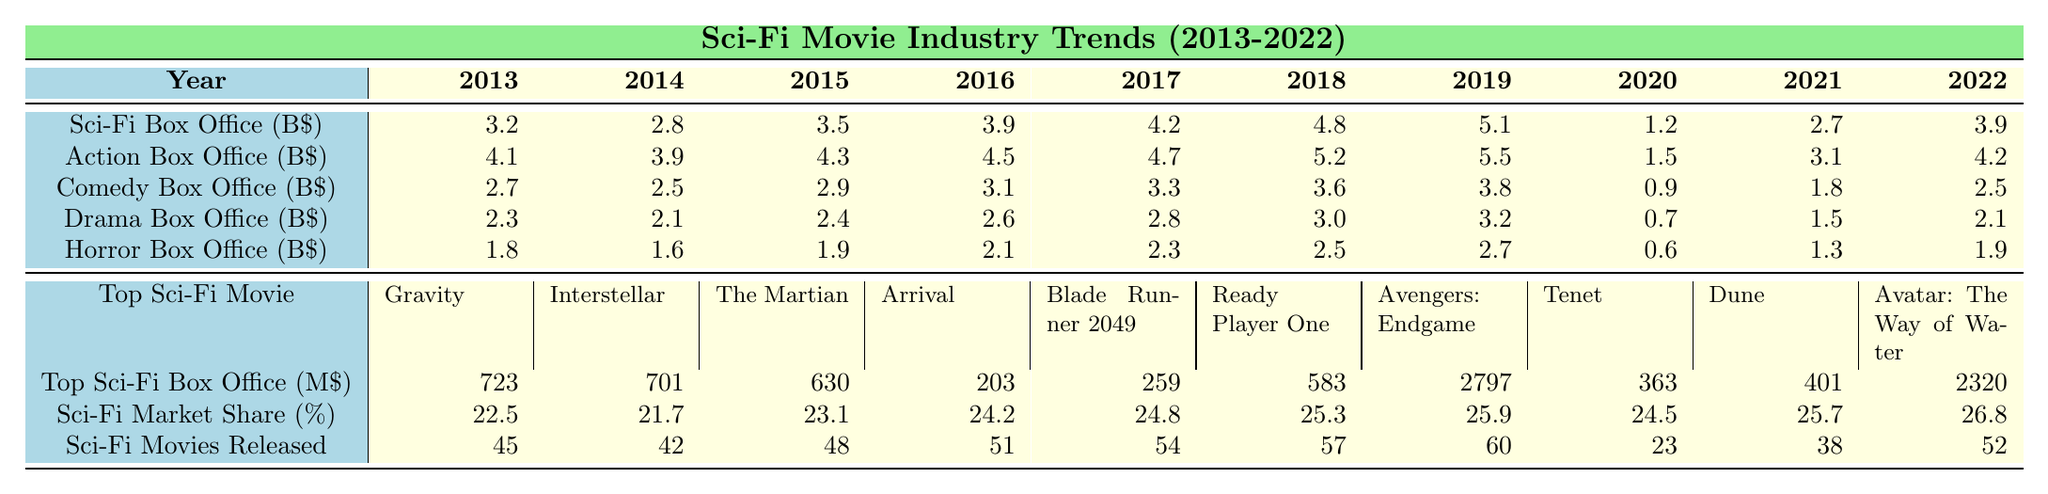What was the highest sci-fi box office revenue in 2019? The table shows that in 2019, the sci-fi box office revenue was 5.1 billion dollars, which is the highest value listed for that year.
Answer: 5.1 billion dollars Which genre had the lowest box office revenue in 2020? In 2020, the box office revenues for all genres are listed. Sci-Fi had 1.2 billion, Action had 1.5 billion, Comedy had 0.9 billion, Drama had 0.7 billion, and Horror had 0.6 billion. Horror had the lowest revenue at 0.6 billion dollars.
Answer: Horror What is the average sci-fi box office revenue from 2013 to 2022? To find the average, sum the sci-fi box office revenues from 2013 to 2022, which gives 3.2 + 2.8 + 3.5 + 3.9 + 4.2 + 4.8 + 5.1 + 1.2 + 2.7 + 3.9 = 31.1 billion dollars. Then divide by 10 (the number of years) to calculate the average: 31.1 / 10 = 3.11 billion dollars.
Answer: 3.11 billion dollars What is the total box office revenue of sci-fi movies from 2013 to 2018? Adding up the sci-fi box office revenues from 2013 to 2018 gives: 3.2 + 2.8 + 3.5 + 3.9 + 4.2 + 4.8 = 22.4 billion dollars.
Answer: 22.4 billion dollars Did the top sci-fi movie in 2018 earn more than that in 2016? The top sci-fi movie in 2018 earned 2797 million dollars, while the top movie in 2016 earned 203 million dollars. Since 2797 million is greater than 203 million, the statement is true.
Answer: Yes Which genre shows the highest market share in 2022? The table lists sci-fi market share as 26.8% in 2022. The other genres' market shares can be deduced to be lower from their revenue figures. Therefore, sci-fi has the highest market share in that year.
Answer: Sci-Fi How many more sci-fi movies were released in 2022 compared to 2020? In 2022, 52 sci-fi movies were released, while in 2020, only 23 were released. The difference is 52 - 23 = 29 more movies released in 2022 compared to 2020.
Answer: 29 more movies What is the trend of sci-fi box office revenue from 2013 to 2022? Observing the sci-fi box office revenue, it generally increased from 3.2 billion in 2013 to a peak of 5.1 billion in 2019, then declined significantly in 2020 to 1.2 billion, only to recover slightly to 3.9 billion in 2022. This indicates a fluctuating trend with peaks and valleys.
Answer: Fluctuating trend Which year had a notable drop in sci-fi box office revenue, and what caused it? The year 2020 had a notable drop in sci-fi box office revenue to 1.2 billion. This was likely due to the COVID-19 pandemic, which caused various restrictions on movie theaters and a general drop in film attendance.
Answer: 2020 What is the percentage increase of sci-fi box office revenue from 2021 to 2022? The revenue in 2021 was 2.7 billion dollars, and in 2022 it rose to 3.9 billion. The increase is 3.9 - 2.7 = 1.2 billion. To find the percentage increase: (1.2 / 2.7) * 100 = approximately 44.44%.
Answer: Approximately 44.44% 